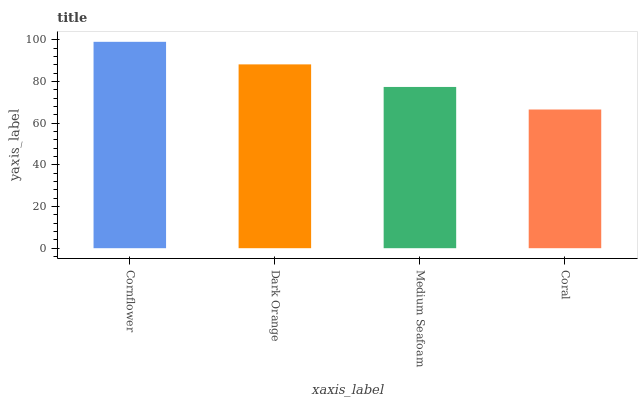Is Coral the minimum?
Answer yes or no. Yes. Is Cornflower the maximum?
Answer yes or no. Yes. Is Dark Orange the minimum?
Answer yes or no. No. Is Dark Orange the maximum?
Answer yes or no. No. Is Cornflower greater than Dark Orange?
Answer yes or no. Yes. Is Dark Orange less than Cornflower?
Answer yes or no. Yes. Is Dark Orange greater than Cornflower?
Answer yes or no. No. Is Cornflower less than Dark Orange?
Answer yes or no. No. Is Dark Orange the high median?
Answer yes or no. Yes. Is Medium Seafoam the low median?
Answer yes or no. Yes. Is Medium Seafoam the high median?
Answer yes or no. No. Is Cornflower the low median?
Answer yes or no. No. 